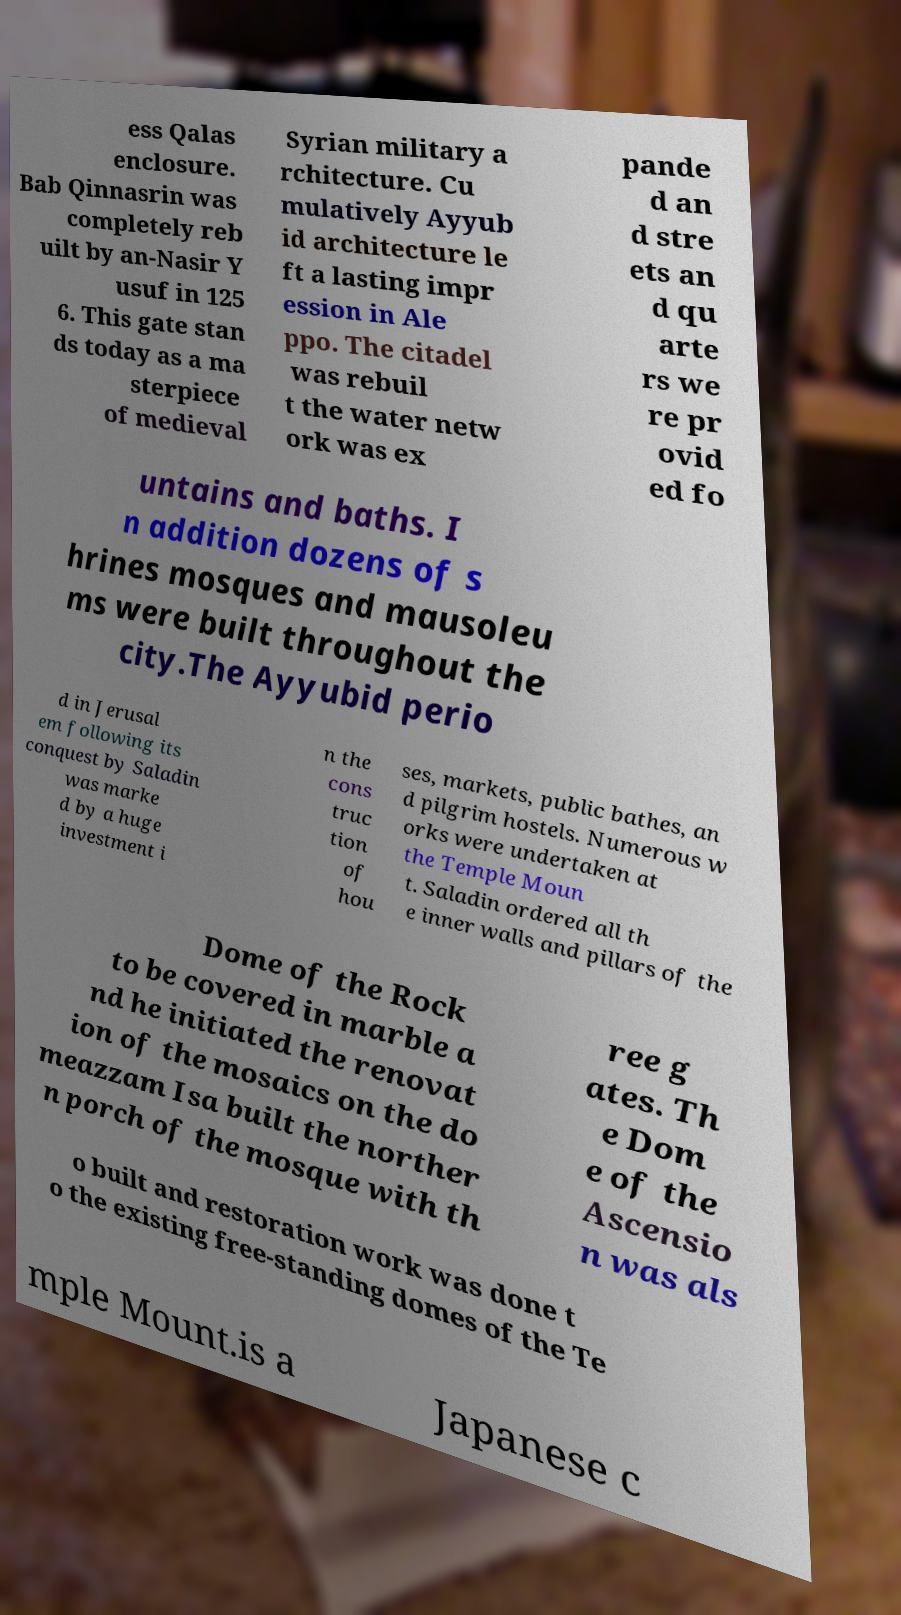Please identify and transcribe the text found in this image. ess Qalas enclosure. Bab Qinnasrin was completely reb uilt by an-Nasir Y usuf in 125 6. This gate stan ds today as a ma sterpiece of medieval Syrian military a rchitecture. Cu mulatively Ayyub id architecture le ft a lasting impr ession in Ale ppo. The citadel was rebuil t the water netw ork was ex pande d an d stre ets an d qu arte rs we re pr ovid ed fo untains and baths. I n addition dozens of s hrines mosques and mausoleu ms were built throughout the city.The Ayyubid perio d in Jerusal em following its conquest by Saladin was marke d by a huge investment i n the cons truc tion of hou ses, markets, public bathes, an d pilgrim hostels. Numerous w orks were undertaken at the Temple Moun t. Saladin ordered all th e inner walls and pillars of the Dome of the Rock to be covered in marble a nd he initiated the renovat ion of the mosaics on the do meazzam Isa built the norther n porch of the mosque with th ree g ates. Th e Dom e of the Ascensio n was als o built and restoration work was done t o the existing free-standing domes of the Te mple Mount.is a Japanese c 